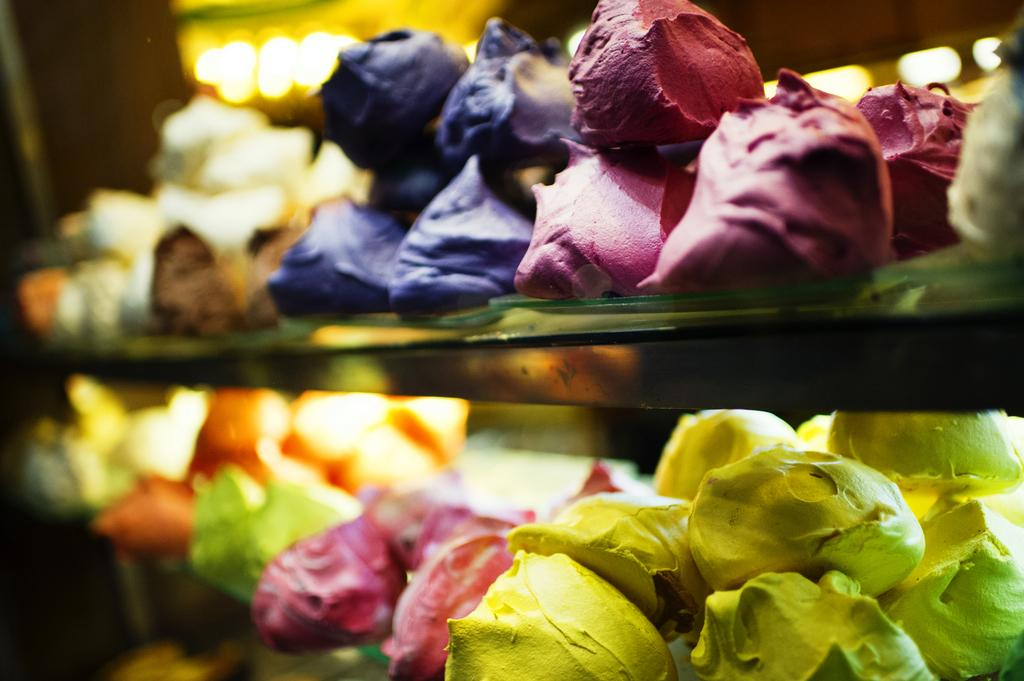What type of objects are present in the image? There are colorful claystones in the image. Can you describe the appearance of the claystones? The claystones are colorful, which suggests they may have various hues or patterns. What type of town can be seen in the background of the image? There is no town visible in the image; it only features colorful claystones. 